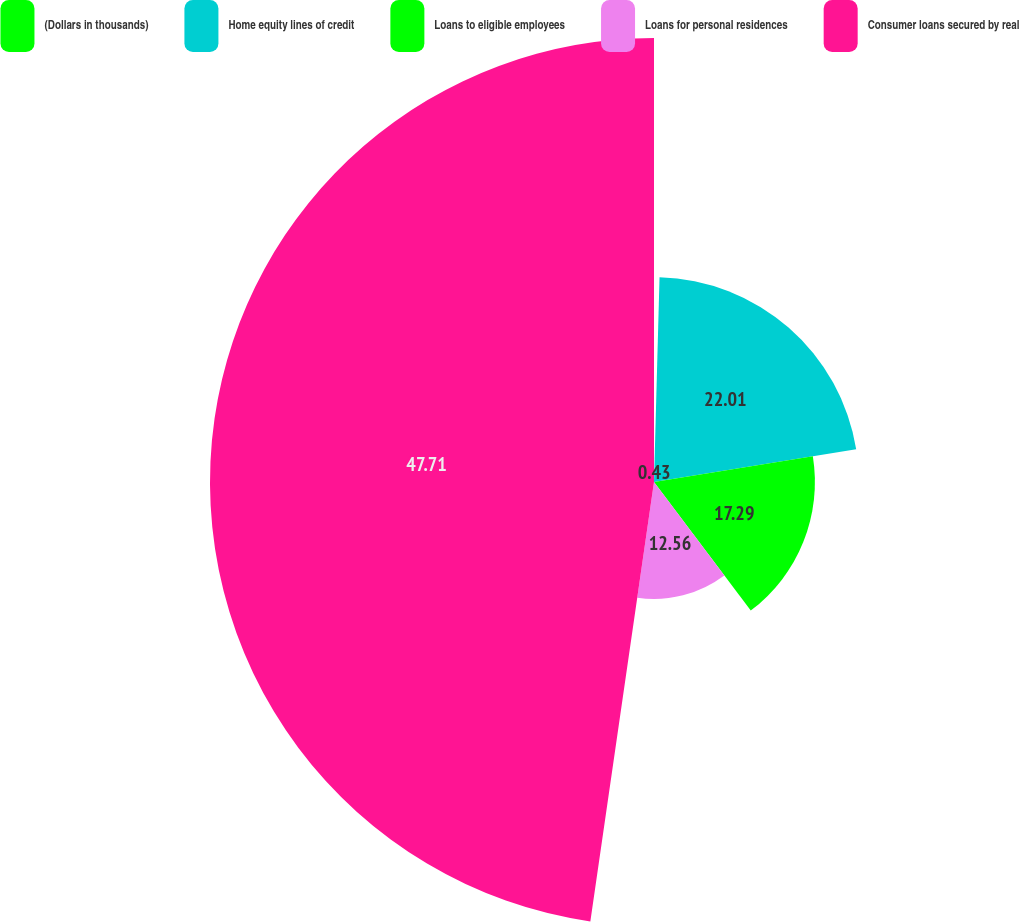<chart> <loc_0><loc_0><loc_500><loc_500><pie_chart><fcel>(Dollars in thousands)<fcel>Home equity lines of credit<fcel>Loans to eligible employees<fcel>Loans for personal residences<fcel>Consumer loans secured by real<nl><fcel>0.43%<fcel>22.01%<fcel>17.29%<fcel>12.56%<fcel>47.71%<nl></chart> 